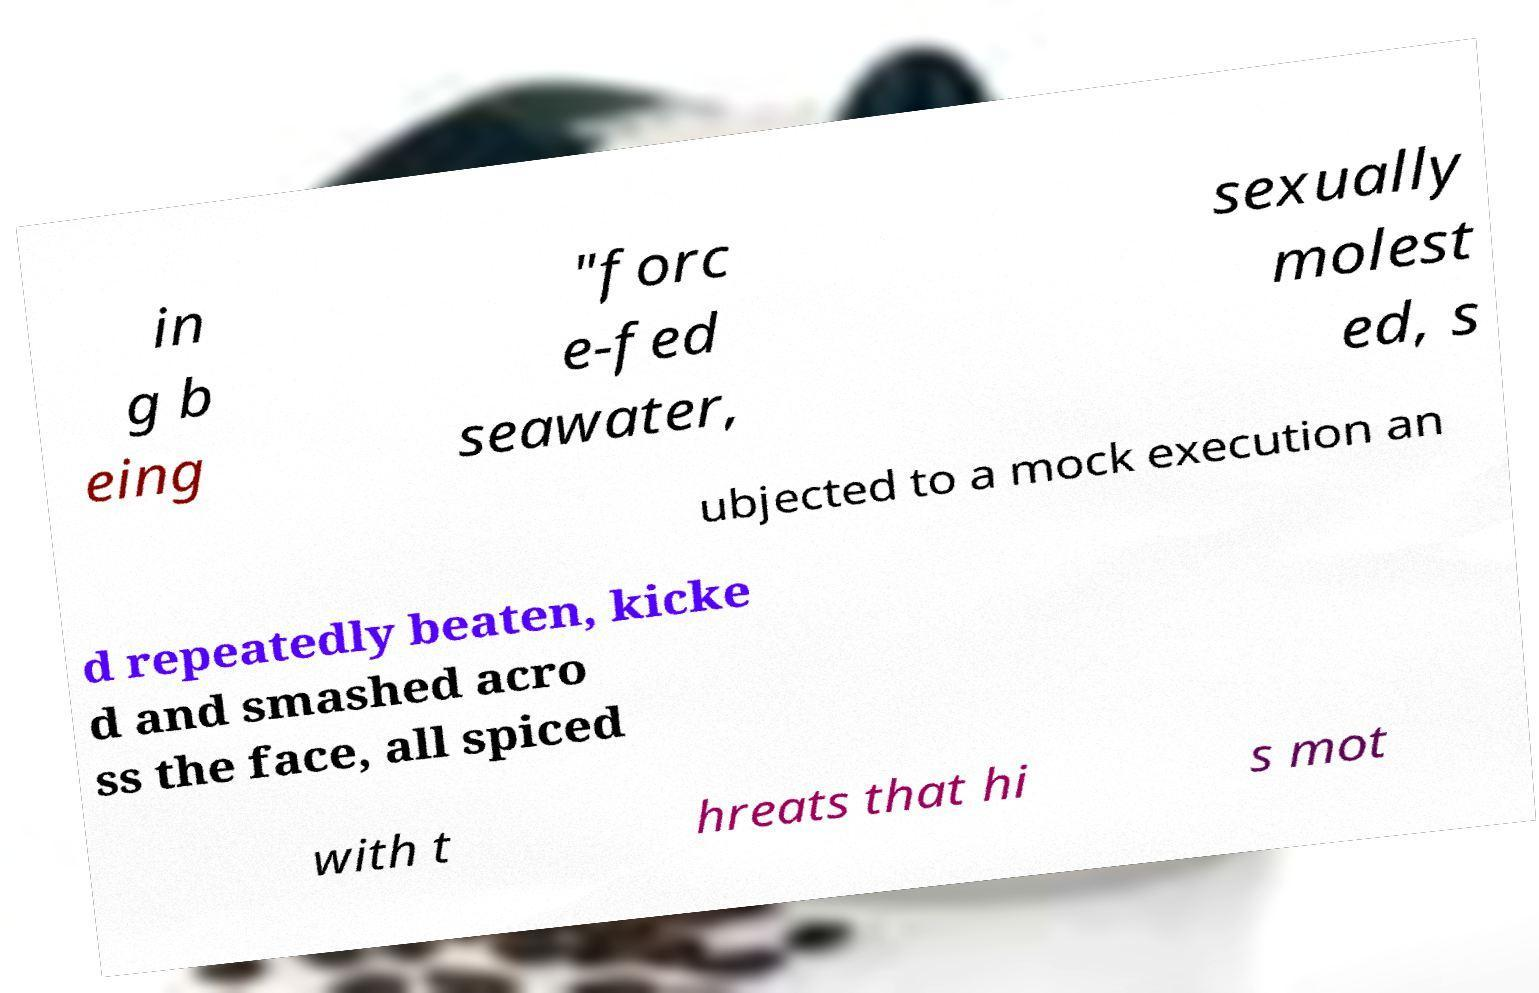There's text embedded in this image that I need extracted. Can you transcribe it verbatim? in g b eing "forc e-fed seawater, sexually molest ed, s ubjected to a mock execution an d repeatedly beaten, kicke d and smashed acro ss the face, all spiced with t hreats that hi s mot 